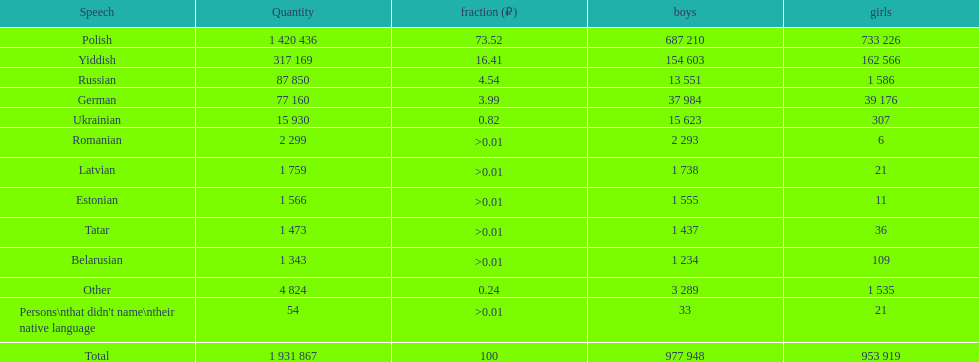Parse the table in full. {'header': ['Speech', 'Quantity', 'fraction (₽)', 'boys', 'girls'], 'rows': [['Polish', '1 420 436', '73.52', '687 210', '733 226'], ['Yiddish', '317 169', '16.41', '154 603', '162 566'], ['Russian', '87 850', '4.54', '13 551', '1 586'], ['German', '77 160', '3.99', '37 984', '39 176'], ['Ukrainian', '15 930', '0.82', '15 623', '307'], ['Romanian', '2 299', '>0.01', '2 293', '6'], ['Latvian', '1 759', '>0.01', '1 738', '21'], ['Estonian', '1 566', '>0.01', '1 555', '11'], ['Tatar', '1 473', '>0.01', '1 437', '36'], ['Belarusian', '1 343', '>0.01', '1 234', '109'], ['Other', '4 824', '0.24', '3 289', '1 535'], ["Persons\\nthat didn't name\\ntheir native language", '54', '>0.01', '33', '21'], ['Total', '1 931 867', '100', '977 948', '953 919']]} When comparing the number of speakers, is german ranked above or below russian? Below. 